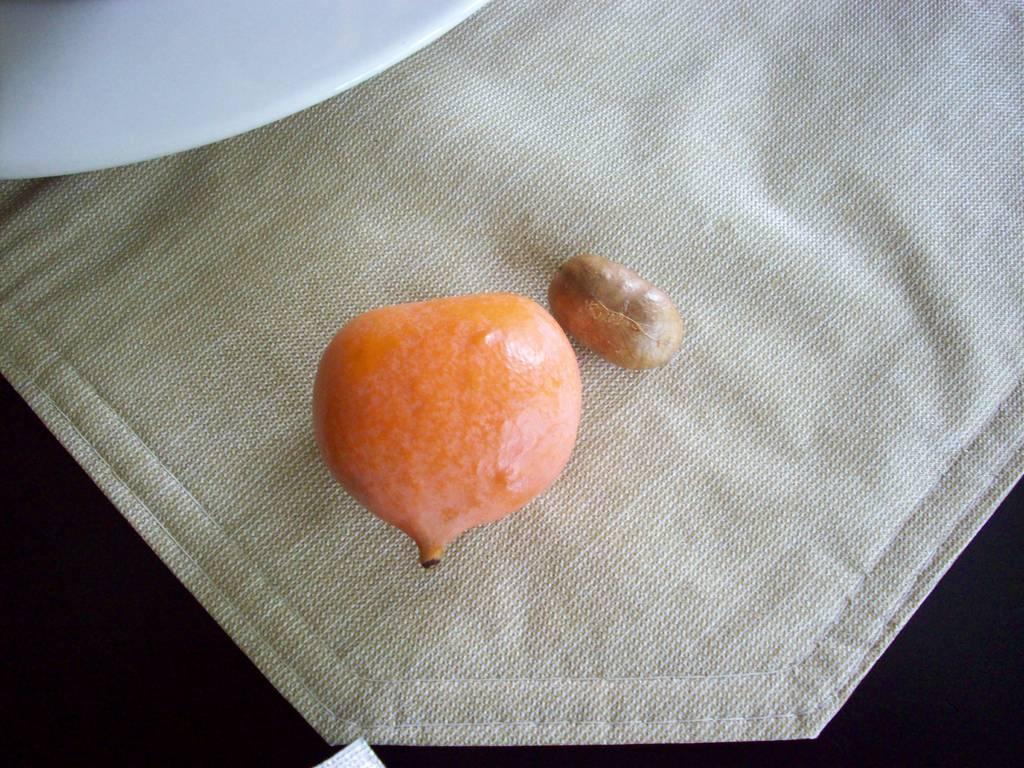How would you summarize this image in a sentence or two? In this image there is a fruit and a seed on a napkin on the table, beside the fruit there is a plate. 